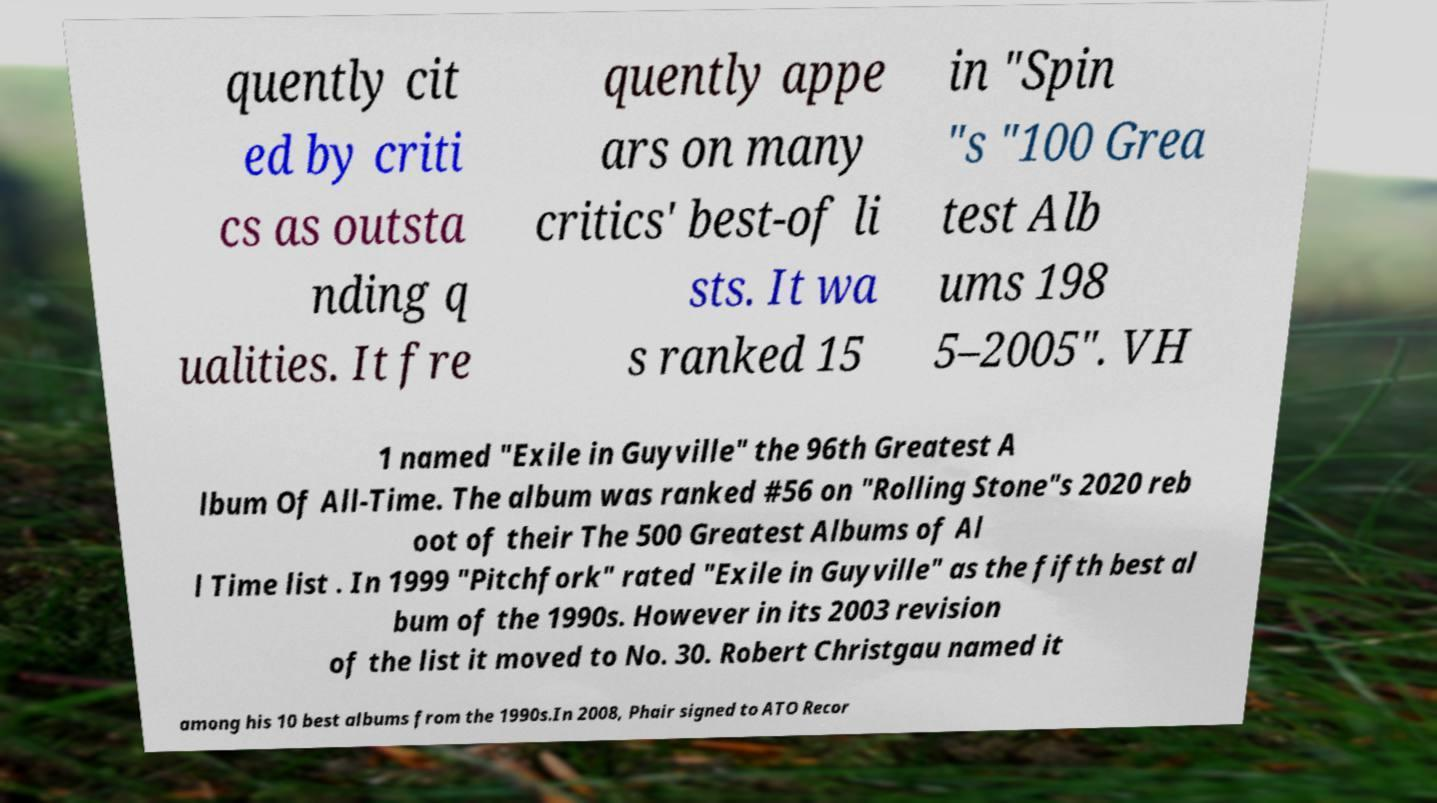I need the written content from this picture converted into text. Can you do that? quently cit ed by criti cs as outsta nding q ualities. It fre quently appe ars on many critics' best-of li sts. It wa s ranked 15 in "Spin "s "100 Grea test Alb ums 198 5–2005". VH 1 named "Exile in Guyville" the 96th Greatest A lbum Of All-Time. The album was ranked #56 on "Rolling Stone"s 2020 reb oot of their The 500 Greatest Albums of Al l Time list . In 1999 "Pitchfork" rated "Exile in Guyville" as the fifth best al bum of the 1990s. However in its 2003 revision of the list it moved to No. 30. Robert Christgau named it among his 10 best albums from the 1990s.In 2008, Phair signed to ATO Recor 